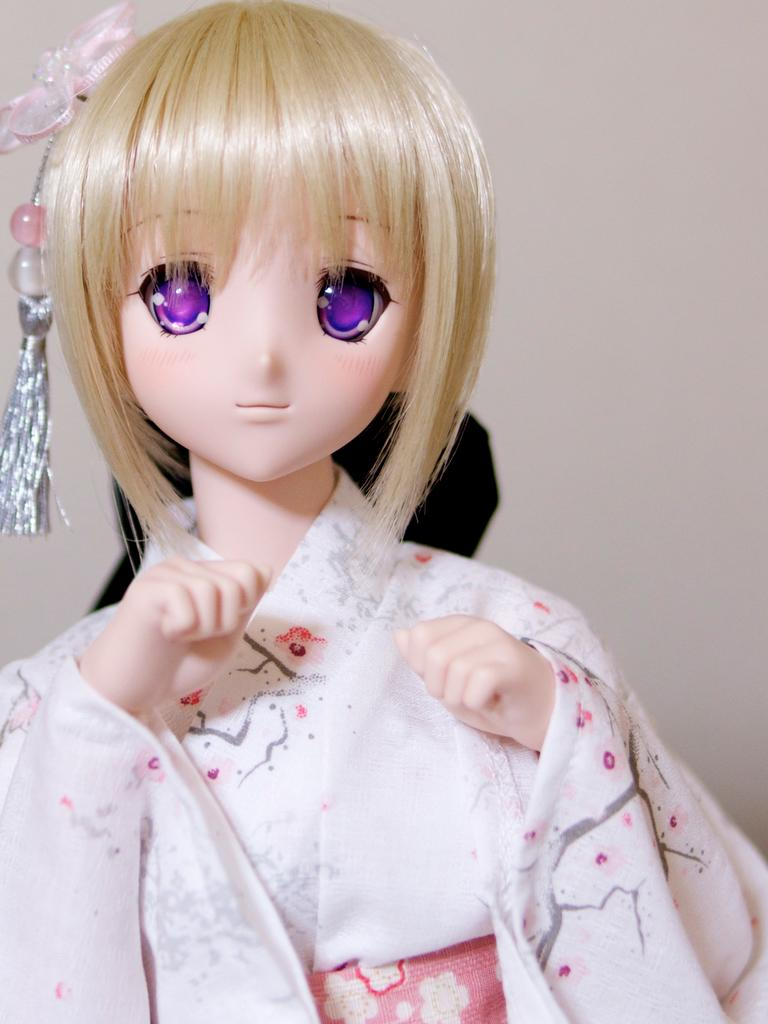What type of doll is in the image? There is a girl doll in the image. What color is the doll's hair? The doll has cream-colored hair. What is the doll wearing? The doll is wearing a white dress. What can be seen in the background of the image? There is a wall in the background of the image. What type of door can be seen in the image? There is no door present in the image; it only features a girl doll and a wall in the background. 